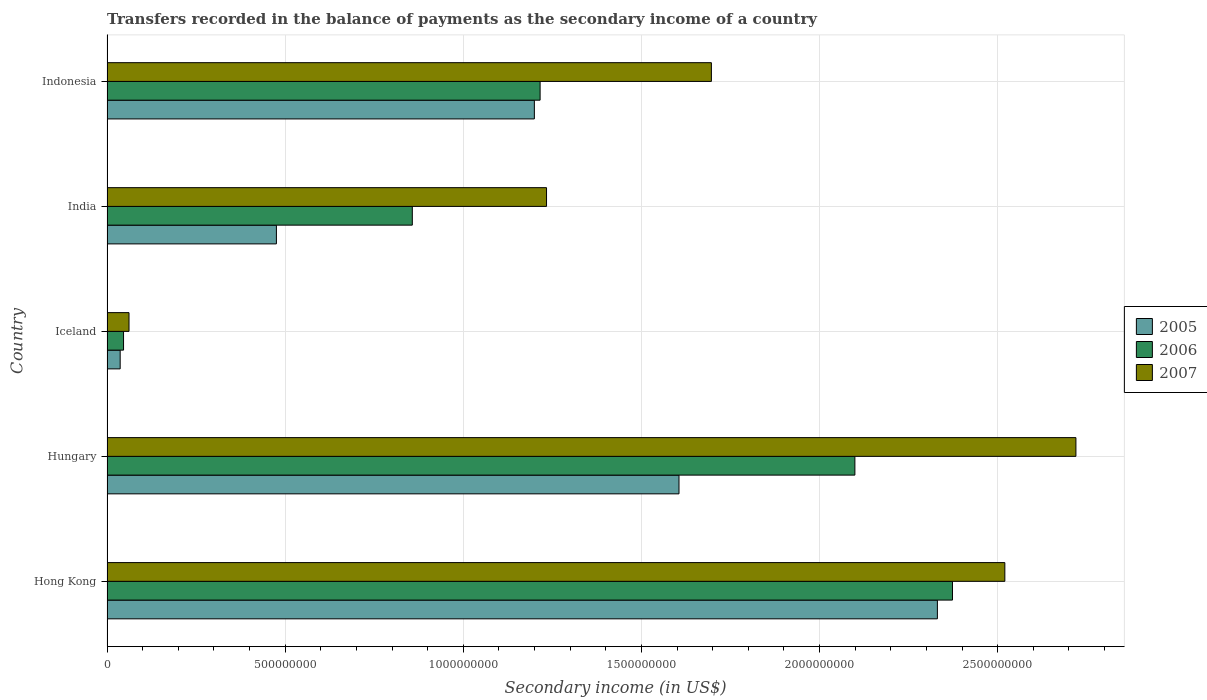How many groups of bars are there?
Ensure brevity in your answer.  5. Are the number of bars per tick equal to the number of legend labels?
Make the answer very short. Yes. Are the number of bars on each tick of the Y-axis equal?
Give a very brief answer. Yes. How many bars are there on the 2nd tick from the top?
Keep it short and to the point. 3. What is the label of the 4th group of bars from the top?
Your answer should be compact. Hungary. What is the secondary income of in 2007 in Hong Kong?
Make the answer very short. 2.52e+09. Across all countries, what is the maximum secondary income of in 2005?
Make the answer very short. 2.33e+09. Across all countries, what is the minimum secondary income of in 2007?
Provide a succinct answer. 6.18e+07. In which country was the secondary income of in 2007 maximum?
Ensure brevity in your answer.  Hungary. What is the total secondary income of in 2007 in the graph?
Provide a succinct answer. 8.23e+09. What is the difference between the secondary income of in 2007 in Hungary and that in Iceland?
Give a very brief answer. 2.66e+09. What is the difference between the secondary income of in 2007 in Iceland and the secondary income of in 2006 in Indonesia?
Keep it short and to the point. -1.15e+09. What is the average secondary income of in 2006 per country?
Keep it short and to the point. 1.32e+09. What is the difference between the secondary income of in 2006 and secondary income of in 2007 in Hungary?
Your response must be concise. -6.20e+08. What is the ratio of the secondary income of in 2007 in Iceland to that in India?
Ensure brevity in your answer.  0.05. Is the secondary income of in 2007 in Hungary less than that in India?
Your answer should be very brief. No. Is the difference between the secondary income of in 2006 in Hungary and Indonesia greater than the difference between the secondary income of in 2007 in Hungary and Indonesia?
Make the answer very short. No. What is the difference between the highest and the second highest secondary income of in 2005?
Your response must be concise. 7.25e+08. What is the difference between the highest and the lowest secondary income of in 2006?
Offer a terse response. 2.33e+09. What does the 2nd bar from the top in Iceland represents?
Your response must be concise. 2006. How many bars are there?
Provide a succinct answer. 15. Are all the bars in the graph horizontal?
Your answer should be very brief. Yes. How many countries are there in the graph?
Provide a succinct answer. 5. What is the difference between two consecutive major ticks on the X-axis?
Provide a short and direct response. 5.00e+08. How many legend labels are there?
Make the answer very short. 3. How are the legend labels stacked?
Ensure brevity in your answer.  Vertical. What is the title of the graph?
Offer a very short reply. Transfers recorded in the balance of payments as the secondary income of a country. What is the label or title of the X-axis?
Keep it short and to the point. Secondary income (in US$). What is the label or title of the Y-axis?
Make the answer very short. Country. What is the Secondary income (in US$) of 2005 in Hong Kong?
Your response must be concise. 2.33e+09. What is the Secondary income (in US$) in 2006 in Hong Kong?
Make the answer very short. 2.37e+09. What is the Secondary income (in US$) in 2007 in Hong Kong?
Keep it short and to the point. 2.52e+09. What is the Secondary income (in US$) in 2005 in Hungary?
Your response must be concise. 1.61e+09. What is the Secondary income (in US$) of 2006 in Hungary?
Your response must be concise. 2.10e+09. What is the Secondary income (in US$) of 2007 in Hungary?
Keep it short and to the point. 2.72e+09. What is the Secondary income (in US$) in 2005 in Iceland?
Provide a short and direct response. 3.70e+07. What is the Secondary income (in US$) in 2006 in Iceland?
Keep it short and to the point. 4.65e+07. What is the Secondary income (in US$) in 2007 in Iceland?
Provide a succinct answer. 6.18e+07. What is the Secondary income (in US$) of 2005 in India?
Ensure brevity in your answer.  4.76e+08. What is the Secondary income (in US$) of 2006 in India?
Your response must be concise. 8.57e+08. What is the Secondary income (in US$) of 2007 in India?
Offer a very short reply. 1.23e+09. What is the Secondary income (in US$) of 2005 in Indonesia?
Your answer should be very brief. 1.20e+09. What is the Secondary income (in US$) of 2006 in Indonesia?
Provide a succinct answer. 1.22e+09. What is the Secondary income (in US$) in 2007 in Indonesia?
Your response must be concise. 1.70e+09. Across all countries, what is the maximum Secondary income (in US$) in 2005?
Your answer should be compact. 2.33e+09. Across all countries, what is the maximum Secondary income (in US$) in 2006?
Offer a very short reply. 2.37e+09. Across all countries, what is the maximum Secondary income (in US$) of 2007?
Offer a terse response. 2.72e+09. Across all countries, what is the minimum Secondary income (in US$) in 2005?
Provide a short and direct response. 3.70e+07. Across all countries, what is the minimum Secondary income (in US$) in 2006?
Your answer should be very brief. 4.65e+07. Across all countries, what is the minimum Secondary income (in US$) of 2007?
Make the answer very short. 6.18e+07. What is the total Secondary income (in US$) in 2005 in the graph?
Make the answer very short. 5.65e+09. What is the total Secondary income (in US$) in 2006 in the graph?
Keep it short and to the point. 6.59e+09. What is the total Secondary income (in US$) in 2007 in the graph?
Ensure brevity in your answer.  8.23e+09. What is the difference between the Secondary income (in US$) in 2005 in Hong Kong and that in Hungary?
Offer a terse response. 7.25e+08. What is the difference between the Secondary income (in US$) in 2006 in Hong Kong and that in Hungary?
Your answer should be compact. 2.74e+08. What is the difference between the Secondary income (in US$) in 2007 in Hong Kong and that in Hungary?
Your answer should be compact. -1.99e+08. What is the difference between the Secondary income (in US$) in 2005 in Hong Kong and that in Iceland?
Provide a succinct answer. 2.29e+09. What is the difference between the Secondary income (in US$) of 2006 in Hong Kong and that in Iceland?
Provide a short and direct response. 2.33e+09. What is the difference between the Secondary income (in US$) of 2007 in Hong Kong and that in Iceland?
Provide a short and direct response. 2.46e+09. What is the difference between the Secondary income (in US$) of 2005 in Hong Kong and that in India?
Your answer should be very brief. 1.86e+09. What is the difference between the Secondary income (in US$) of 2006 in Hong Kong and that in India?
Your answer should be compact. 1.52e+09. What is the difference between the Secondary income (in US$) of 2007 in Hong Kong and that in India?
Provide a short and direct response. 1.29e+09. What is the difference between the Secondary income (in US$) in 2005 in Hong Kong and that in Indonesia?
Offer a terse response. 1.13e+09. What is the difference between the Secondary income (in US$) in 2006 in Hong Kong and that in Indonesia?
Provide a succinct answer. 1.16e+09. What is the difference between the Secondary income (in US$) in 2007 in Hong Kong and that in Indonesia?
Offer a terse response. 8.24e+08. What is the difference between the Secondary income (in US$) of 2005 in Hungary and that in Iceland?
Offer a very short reply. 1.57e+09. What is the difference between the Secondary income (in US$) of 2006 in Hungary and that in Iceland?
Give a very brief answer. 2.05e+09. What is the difference between the Secondary income (in US$) of 2007 in Hungary and that in Iceland?
Your response must be concise. 2.66e+09. What is the difference between the Secondary income (in US$) of 2005 in Hungary and that in India?
Keep it short and to the point. 1.13e+09. What is the difference between the Secondary income (in US$) of 2006 in Hungary and that in India?
Ensure brevity in your answer.  1.24e+09. What is the difference between the Secondary income (in US$) in 2007 in Hungary and that in India?
Make the answer very short. 1.49e+09. What is the difference between the Secondary income (in US$) of 2005 in Hungary and that in Indonesia?
Offer a very short reply. 4.06e+08. What is the difference between the Secondary income (in US$) of 2006 in Hungary and that in Indonesia?
Make the answer very short. 8.84e+08. What is the difference between the Secondary income (in US$) of 2007 in Hungary and that in Indonesia?
Your answer should be compact. 1.02e+09. What is the difference between the Secondary income (in US$) in 2005 in Iceland and that in India?
Offer a very short reply. -4.39e+08. What is the difference between the Secondary income (in US$) of 2006 in Iceland and that in India?
Give a very brief answer. -8.11e+08. What is the difference between the Secondary income (in US$) in 2007 in Iceland and that in India?
Provide a short and direct response. -1.17e+09. What is the difference between the Secondary income (in US$) in 2005 in Iceland and that in Indonesia?
Provide a short and direct response. -1.16e+09. What is the difference between the Secondary income (in US$) in 2006 in Iceland and that in Indonesia?
Make the answer very short. -1.17e+09. What is the difference between the Secondary income (in US$) of 2007 in Iceland and that in Indonesia?
Your answer should be very brief. -1.63e+09. What is the difference between the Secondary income (in US$) of 2005 in India and that in Indonesia?
Provide a short and direct response. -7.24e+08. What is the difference between the Secondary income (in US$) of 2006 in India and that in Indonesia?
Offer a very short reply. -3.59e+08. What is the difference between the Secondary income (in US$) in 2007 in India and that in Indonesia?
Ensure brevity in your answer.  -4.63e+08. What is the difference between the Secondary income (in US$) of 2005 in Hong Kong and the Secondary income (in US$) of 2006 in Hungary?
Make the answer very short. 2.32e+08. What is the difference between the Secondary income (in US$) in 2005 in Hong Kong and the Secondary income (in US$) in 2007 in Hungary?
Give a very brief answer. -3.89e+08. What is the difference between the Secondary income (in US$) of 2006 in Hong Kong and the Secondary income (in US$) of 2007 in Hungary?
Offer a terse response. -3.47e+08. What is the difference between the Secondary income (in US$) of 2005 in Hong Kong and the Secondary income (in US$) of 2006 in Iceland?
Offer a very short reply. 2.28e+09. What is the difference between the Secondary income (in US$) of 2005 in Hong Kong and the Secondary income (in US$) of 2007 in Iceland?
Your response must be concise. 2.27e+09. What is the difference between the Secondary income (in US$) in 2006 in Hong Kong and the Secondary income (in US$) in 2007 in Iceland?
Keep it short and to the point. 2.31e+09. What is the difference between the Secondary income (in US$) in 2005 in Hong Kong and the Secondary income (in US$) in 2006 in India?
Give a very brief answer. 1.47e+09. What is the difference between the Secondary income (in US$) in 2005 in Hong Kong and the Secondary income (in US$) in 2007 in India?
Provide a short and direct response. 1.10e+09. What is the difference between the Secondary income (in US$) of 2006 in Hong Kong and the Secondary income (in US$) of 2007 in India?
Offer a very short reply. 1.14e+09. What is the difference between the Secondary income (in US$) in 2005 in Hong Kong and the Secondary income (in US$) in 2006 in Indonesia?
Keep it short and to the point. 1.12e+09. What is the difference between the Secondary income (in US$) of 2005 in Hong Kong and the Secondary income (in US$) of 2007 in Indonesia?
Your answer should be compact. 6.34e+08. What is the difference between the Secondary income (in US$) in 2006 in Hong Kong and the Secondary income (in US$) in 2007 in Indonesia?
Ensure brevity in your answer.  6.77e+08. What is the difference between the Secondary income (in US$) of 2005 in Hungary and the Secondary income (in US$) of 2006 in Iceland?
Your answer should be very brief. 1.56e+09. What is the difference between the Secondary income (in US$) in 2005 in Hungary and the Secondary income (in US$) in 2007 in Iceland?
Make the answer very short. 1.54e+09. What is the difference between the Secondary income (in US$) in 2006 in Hungary and the Secondary income (in US$) in 2007 in Iceland?
Ensure brevity in your answer.  2.04e+09. What is the difference between the Secondary income (in US$) in 2005 in Hungary and the Secondary income (in US$) in 2006 in India?
Offer a very short reply. 7.49e+08. What is the difference between the Secondary income (in US$) of 2005 in Hungary and the Secondary income (in US$) of 2007 in India?
Provide a short and direct response. 3.72e+08. What is the difference between the Secondary income (in US$) of 2006 in Hungary and the Secondary income (in US$) of 2007 in India?
Provide a succinct answer. 8.66e+08. What is the difference between the Secondary income (in US$) in 2005 in Hungary and the Secondary income (in US$) in 2006 in Indonesia?
Your answer should be very brief. 3.90e+08. What is the difference between the Secondary income (in US$) of 2005 in Hungary and the Secondary income (in US$) of 2007 in Indonesia?
Provide a short and direct response. -9.09e+07. What is the difference between the Secondary income (in US$) of 2006 in Hungary and the Secondary income (in US$) of 2007 in Indonesia?
Provide a succinct answer. 4.03e+08. What is the difference between the Secondary income (in US$) in 2005 in Iceland and the Secondary income (in US$) in 2006 in India?
Provide a succinct answer. -8.20e+08. What is the difference between the Secondary income (in US$) in 2005 in Iceland and the Secondary income (in US$) in 2007 in India?
Your answer should be very brief. -1.20e+09. What is the difference between the Secondary income (in US$) in 2006 in Iceland and the Secondary income (in US$) in 2007 in India?
Offer a very short reply. -1.19e+09. What is the difference between the Secondary income (in US$) in 2005 in Iceland and the Secondary income (in US$) in 2006 in Indonesia?
Your response must be concise. -1.18e+09. What is the difference between the Secondary income (in US$) in 2005 in Iceland and the Secondary income (in US$) in 2007 in Indonesia?
Offer a terse response. -1.66e+09. What is the difference between the Secondary income (in US$) of 2006 in Iceland and the Secondary income (in US$) of 2007 in Indonesia?
Give a very brief answer. -1.65e+09. What is the difference between the Secondary income (in US$) of 2005 in India and the Secondary income (in US$) of 2006 in Indonesia?
Offer a very short reply. -7.40e+08. What is the difference between the Secondary income (in US$) of 2005 in India and the Secondary income (in US$) of 2007 in Indonesia?
Your response must be concise. -1.22e+09. What is the difference between the Secondary income (in US$) in 2006 in India and the Secondary income (in US$) in 2007 in Indonesia?
Ensure brevity in your answer.  -8.39e+08. What is the average Secondary income (in US$) in 2005 per country?
Make the answer very short. 1.13e+09. What is the average Secondary income (in US$) of 2006 per country?
Your answer should be very brief. 1.32e+09. What is the average Secondary income (in US$) of 2007 per country?
Keep it short and to the point. 1.65e+09. What is the difference between the Secondary income (in US$) of 2005 and Secondary income (in US$) of 2006 in Hong Kong?
Your response must be concise. -4.24e+07. What is the difference between the Secondary income (in US$) of 2005 and Secondary income (in US$) of 2007 in Hong Kong?
Your answer should be very brief. -1.89e+08. What is the difference between the Secondary income (in US$) in 2006 and Secondary income (in US$) in 2007 in Hong Kong?
Your answer should be very brief. -1.47e+08. What is the difference between the Secondary income (in US$) in 2005 and Secondary income (in US$) in 2006 in Hungary?
Give a very brief answer. -4.94e+08. What is the difference between the Secondary income (in US$) of 2005 and Secondary income (in US$) of 2007 in Hungary?
Your answer should be very brief. -1.11e+09. What is the difference between the Secondary income (in US$) of 2006 and Secondary income (in US$) of 2007 in Hungary?
Your answer should be very brief. -6.20e+08. What is the difference between the Secondary income (in US$) in 2005 and Secondary income (in US$) in 2006 in Iceland?
Offer a very short reply. -9.48e+06. What is the difference between the Secondary income (in US$) in 2005 and Secondary income (in US$) in 2007 in Iceland?
Your answer should be compact. -2.48e+07. What is the difference between the Secondary income (in US$) of 2006 and Secondary income (in US$) of 2007 in Iceland?
Make the answer very short. -1.53e+07. What is the difference between the Secondary income (in US$) in 2005 and Secondary income (in US$) in 2006 in India?
Offer a very short reply. -3.82e+08. What is the difference between the Secondary income (in US$) in 2005 and Secondary income (in US$) in 2007 in India?
Make the answer very short. -7.58e+08. What is the difference between the Secondary income (in US$) in 2006 and Secondary income (in US$) in 2007 in India?
Your answer should be compact. -3.77e+08. What is the difference between the Secondary income (in US$) in 2005 and Secondary income (in US$) in 2006 in Indonesia?
Make the answer very short. -1.61e+07. What is the difference between the Secondary income (in US$) in 2005 and Secondary income (in US$) in 2007 in Indonesia?
Offer a terse response. -4.97e+08. What is the difference between the Secondary income (in US$) in 2006 and Secondary income (in US$) in 2007 in Indonesia?
Give a very brief answer. -4.81e+08. What is the ratio of the Secondary income (in US$) of 2005 in Hong Kong to that in Hungary?
Give a very brief answer. 1.45. What is the ratio of the Secondary income (in US$) of 2006 in Hong Kong to that in Hungary?
Your answer should be compact. 1.13. What is the ratio of the Secondary income (in US$) in 2007 in Hong Kong to that in Hungary?
Your answer should be compact. 0.93. What is the ratio of the Secondary income (in US$) of 2005 in Hong Kong to that in Iceland?
Your response must be concise. 63.04. What is the ratio of the Secondary income (in US$) of 2006 in Hong Kong to that in Iceland?
Offer a very short reply. 51.09. What is the ratio of the Secondary income (in US$) of 2007 in Hong Kong to that in Iceland?
Ensure brevity in your answer.  40.8. What is the ratio of the Secondary income (in US$) of 2005 in Hong Kong to that in India?
Your response must be concise. 4.9. What is the ratio of the Secondary income (in US$) in 2006 in Hong Kong to that in India?
Provide a short and direct response. 2.77. What is the ratio of the Secondary income (in US$) of 2007 in Hong Kong to that in India?
Your response must be concise. 2.04. What is the ratio of the Secondary income (in US$) in 2005 in Hong Kong to that in Indonesia?
Your answer should be compact. 1.94. What is the ratio of the Secondary income (in US$) in 2006 in Hong Kong to that in Indonesia?
Give a very brief answer. 1.95. What is the ratio of the Secondary income (in US$) of 2007 in Hong Kong to that in Indonesia?
Keep it short and to the point. 1.49. What is the ratio of the Secondary income (in US$) in 2005 in Hungary to that in Iceland?
Ensure brevity in your answer.  43.42. What is the ratio of the Secondary income (in US$) of 2006 in Hungary to that in Iceland?
Your answer should be very brief. 45.19. What is the ratio of the Secondary income (in US$) in 2007 in Hungary to that in Iceland?
Provide a succinct answer. 44.03. What is the ratio of the Secondary income (in US$) in 2005 in Hungary to that in India?
Your response must be concise. 3.38. What is the ratio of the Secondary income (in US$) in 2006 in Hungary to that in India?
Your answer should be very brief. 2.45. What is the ratio of the Secondary income (in US$) in 2007 in Hungary to that in India?
Offer a terse response. 2.2. What is the ratio of the Secondary income (in US$) of 2005 in Hungary to that in Indonesia?
Make the answer very short. 1.34. What is the ratio of the Secondary income (in US$) in 2006 in Hungary to that in Indonesia?
Give a very brief answer. 1.73. What is the ratio of the Secondary income (in US$) of 2007 in Hungary to that in Indonesia?
Make the answer very short. 1.6. What is the ratio of the Secondary income (in US$) in 2005 in Iceland to that in India?
Offer a very short reply. 0.08. What is the ratio of the Secondary income (in US$) of 2006 in Iceland to that in India?
Keep it short and to the point. 0.05. What is the ratio of the Secondary income (in US$) in 2007 in Iceland to that in India?
Ensure brevity in your answer.  0.05. What is the ratio of the Secondary income (in US$) of 2005 in Iceland to that in Indonesia?
Provide a short and direct response. 0.03. What is the ratio of the Secondary income (in US$) of 2006 in Iceland to that in Indonesia?
Provide a succinct answer. 0.04. What is the ratio of the Secondary income (in US$) in 2007 in Iceland to that in Indonesia?
Your response must be concise. 0.04. What is the ratio of the Secondary income (in US$) in 2005 in India to that in Indonesia?
Offer a terse response. 0.4. What is the ratio of the Secondary income (in US$) in 2006 in India to that in Indonesia?
Your answer should be very brief. 0.7. What is the ratio of the Secondary income (in US$) in 2007 in India to that in Indonesia?
Provide a succinct answer. 0.73. What is the difference between the highest and the second highest Secondary income (in US$) in 2005?
Offer a terse response. 7.25e+08. What is the difference between the highest and the second highest Secondary income (in US$) in 2006?
Make the answer very short. 2.74e+08. What is the difference between the highest and the second highest Secondary income (in US$) in 2007?
Provide a succinct answer. 1.99e+08. What is the difference between the highest and the lowest Secondary income (in US$) of 2005?
Make the answer very short. 2.29e+09. What is the difference between the highest and the lowest Secondary income (in US$) in 2006?
Give a very brief answer. 2.33e+09. What is the difference between the highest and the lowest Secondary income (in US$) in 2007?
Ensure brevity in your answer.  2.66e+09. 